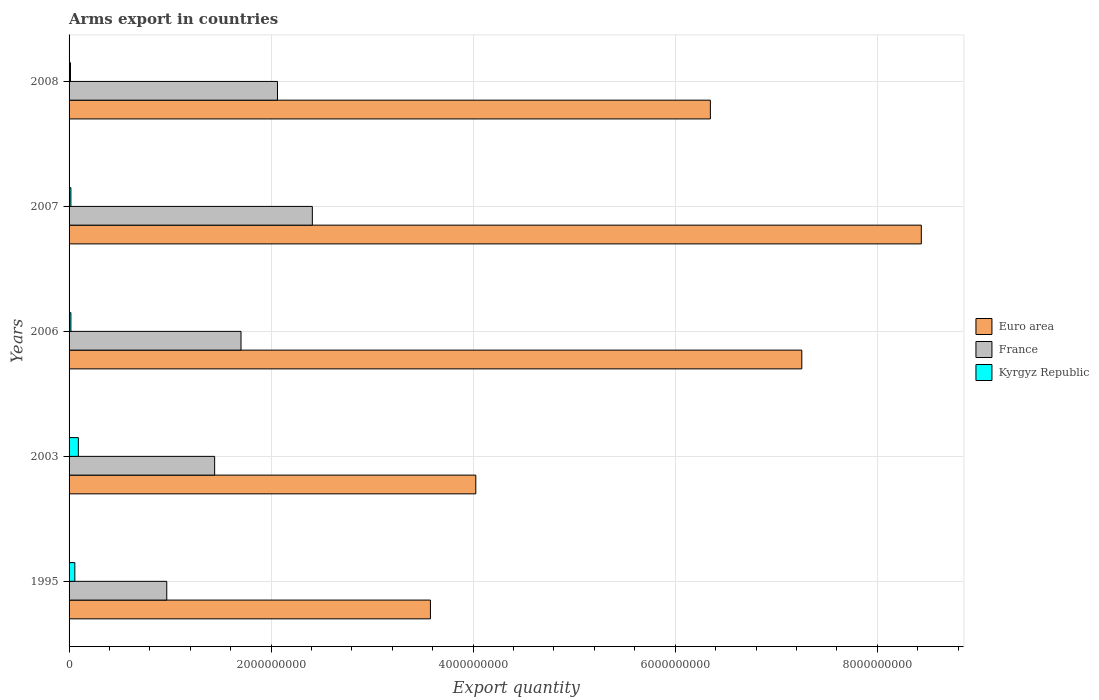Are the number of bars on each tick of the Y-axis equal?
Your answer should be compact. Yes. How many bars are there on the 3rd tick from the top?
Keep it short and to the point. 3. In how many cases, is the number of bars for a given year not equal to the number of legend labels?
Offer a terse response. 0. What is the total arms export in France in 2003?
Ensure brevity in your answer.  1.44e+09. Across all years, what is the maximum total arms export in Kyrgyz Republic?
Offer a very short reply. 9.20e+07. Across all years, what is the minimum total arms export in France?
Your answer should be very brief. 9.67e+08. What is the total total arms export in Euro area in the graph?
Make the answer very short. 2.96e+1. What is the difference between the total arms export in France in 2007 and that in 2008?
Keep it short and to the point. 3.45e+08. What is the difference between the total arms export in Euro area in 2006 and the total arms export in Kyrgyz Republic in 2003?
Your answer should be very brief. 7.16e+09. What is the average total arms export in France per year?
Your answer should be compact. 1.72e+09. In the year 2007, what is the difference between the total arms export in Euro area and total arms export in Kyrgyz Republic?
Make the answer very short. 8.42e+09. What is the ratio of the total arms export in Euro area in 2003 to that in 2006?
Offer a very short reply. 0.56. Is the total arms export in Euro area in 2003 less than that in 2006?
Make the answer very short. Yes. What is the difference between the highest and the second highest total arms export in Kyrgyz Republic?
Your answer should be compact. 3.50e+07. What is the difference between the highest and the lowest total arms export in France?
Your answer should be compact. 1.44e+09. Is the sum of the total arms export in Euro area in 1995 and 2008 greater than the maximum total arms export in Kyrgyz Republic across all years?
Make the answer very short. Yes. What does the 1st bar from the top in 1995 represents?
Keep it short and to the point. Kyrgyz Republic. What does the 3rd bar from the bottom in 2003 represents?
Your response must be concise. Kyrgyz Republic. How many bars are there?
Provide a succinct answer. 15. How many years are there in the graph?
Give a very brief answer. 5. What is the difference between two consecutive major ticks on the X-axis?
Provide a short and direct response. 2.00e+09. Does the graph contain grids?
Offer a very short reply. Yes. Where does the legend appear in the graph?
Your answer should be very brief. Center right. How are the legend labels stacked?
Keep it short and to the point. Vertical. What is the title of the graph?
Offer a very short reply. Arms export in countries. What is the label or title of the X-axis?
Your response must be concise. Export quantity. What is the Export quantity in Euro area in 1995?
Your answer should be very brief. 3.58e+09. What is the Export quantity of France in 1995?
Offer a terse response. 9.67e+08. What is the Export quantity in Kyrgyz Republic in 1995?
Give a very brief answer. 5.70e+07. What is the Export quantity in Euro area in 2003?
Make the answer very short. 4.03e+09. What is the Export quantity of France in 2003?
Your answer should be compact. 1.44e+09. What is the Export quantity of Kyrgyz Republic in 2003?
Provide a succinct answer. 9.20e+07. What is the Export quantity of Euro area in 2006?
Offer a terse response. 7.25e+09. What is the Export quantity of France in 2006?
Your response must be concise. 1.70e+09. What is the Export quantity of Kyrgyz Republic in 2006?
Keep it short and to the point. 1.80e+07. What is the Export quantity of Euro area in 2007?
Give a very brief answer. 8.44e+09. What is the Export quantity of France in 2007?
Offer a very short reply. 2.41e+09. What is the Export quantity in Kyrgyz Republic in 2007?
Offer a very short reply. 1.80e+07. What is the Export quantity of Euro area in 2008?
Provide a succinct answer. 6.35e+09. What is the Export quantity of France in 2008?
Provide a succinct answer. 2.06e+09. What is the Export quantity of Kyrgyz Republic in 2008?
Your answer should be compact. 1.40e+07. Across all years, what is the maximum Export quantity of Euro area?
Give a very brief answer. 8.44e+09. Across all years, what is the maximum Export quantity of France?
Your answer should be very brief. 2.41e+09. Across all years, what is the maximum Export quantity of Kyrgyz Republic?
Your answer should be very brief. 9.20e+07. Across all years, what is the minimum Export quantity of Euro area?
Make the answer very short. 3.58e+09. Across all years, what is the minimum Export quantity of France?
Your answer should be compact. 9.67e+08. Across all years, what is the minimum Export quantity of Kyrgyz Republic?
Your answer should be compact. 1.40e+07. What is the total Export quantity in Euro area in the graph?
Your answer should be compact. 2.96e+1. What is the total Export quantity of France in the graph?
Provide a short and direct response. 8.58e+09. What is the total Export quantity of Kyrgyz Republic in the graph?
Your answer should be very brief. 1.99e+08. What is the difference between the Export quantity of Euro area in 1995 and that in 2003?
Your response must be concise. -4.49e+08. What is the difference between the Export quantity in France in 1995 and that in 2003?
Your answer should be very brief. -4.74e+08. What is the difference between the Export quantity of Kyrgyz Republic in 1995 and that in 2003?
Your response must be concise. -3.50e+07. What is the difference between the Export quantity of Euro area in 1995 and that in 2006?
Your answer should be compact. -3.68e+09. What is the difference between the Export quantity of France in 1995 and that in 2006?
Your answer should be compact. -7.35e+08. What is the difference between the Export quantity of Kyrgyz Republic in 1995 and that in 2006?
Your answer should be very brief. 3.90e+07. What is the difference between the Export quantity of Euro area in 1995 and that in 2007?
Provide a short and direct response. -4.86e+09. What is the difference between the Export quantity in France in 1995 and that in 2007?
Keep it short and to the point. -1.44e+09. What is the difference between the Export quantity of Kyrgyz Republic in 1995 and that in 2007?
Your response must be concise. 3.90e+07. What is the difference between the Export quantity in Euro area in 1995 and that in 2008?
Offer a terse response. -2.77e+09. What is the difference between the Export quantity of France in 1995 and that in 2008?
Give a very brief answer. -1.10e+09. What is the difference between the Export quantity in Kyrgyz Republic in 1995 and that in 2008?
Give a very brief answer. 4.30e+07. What is the difference between the Export quantity in Euro area in 2003 and that in 2006?
Offer a very short reply. -3.23e+09. What is the difference between the Export quantity in France in 2003 and that in 2006?
Offer a terse response. -2.61e+08. What is the difference between the Export quantity in Kyrgyz Republic in 2003 and that in 2006?
Offer a very short reply. 7.40e+07. What is the difference between the Export quantity of Euro area in 2003 and that in 2007?
Offer a very short reply. -4.41e+09. What is the difference between the Export quantity in France in 2003 and that in 2007?
Provide a succinct answer. -9.67e+08. What is the difference between the Export quantity of Kyrgyz Republic in 2003 and that in 2007?
Provide a short and direct response. 7.40e+07. What is the difference between the Export quantity of Euro area in 2003 and that in 2008?
Provide a succinct answer. -2.32e+09. What is the difference between the Export quantity in France in 2003 and that in 2008?
Your answer should be compact. -6.22e+08. What is the difference between the Export quantity in Kyrgyz Republic in 2003 and that in 2008?
Give a very brief answer. 7.80e+07. What is the difference between the Export quantity of Euro area in 2006 and that in 2007?
Your answer should be very brief. -1.18e+09. What is the difference between the Export quantity in France in 2006 and that in 2007?
Offer a terse response. -7.06e+08. What is the difference between the Export quantity of Euro area in 2006 and that in 2008?
Keep it short and to the point. 9.05e+08. What is the difference between the Export quantity in France in 2006 and that in 2008?
Keep it short and to the point. -3.61e+08. What is the difference between the Export quantity in Euro area in 2007 and that in 2008?
Your answer should be compact. 2.09e+09. What is the difference between the Export quantity of France in 2007 and that in 2008?
Give a very brief answer. 3.45e+08. What is the difference between the Export quantity of Euro area in 1995 and the Export quantity of France in 2003?
Offer a terse response. 2.14e+09. What is the difference between the Export quantity in Euro area in 1995 and the Export quantity in Kyrgyz Republic in 2003?
Offer a very short reply. 3.48e+09. What is the difference between the Export quantity of France in 1995 and the Export quantity of Kyrgyz Republic in 2003?
Offer a terse response. 8.75e+08. What is the difference between the Export quantity in Euro area in 1995 and the Export quantity in France in 2006?
Provide a succinct answer. 1.88e+09. What is the difference between the Export quantity of Euro area in 1995 and the Export quantity of Kyrgyz Republic in 2006?
Your response must be concise. 3.56e+09. What is the difference between the Export quantity of France in 1995 and the Export quantity of Kyrgyz Republic in 2006?
Offer a terse response. 9.49e+08. What is the difference between the Export quantity of Euro area in 1995 and the Export quantity of France in 2007?
Offer a very short reply. 1.17e+09. What is the difference between the Export quantity in Euro area in 1995 and the Export quantity in Kyrgyz Republic in 2007?
Ensure brevity in your answer.  3.56e+09. What is the difference between the Export quantity of France in 1995 and the Export quantity of Kyrgyz Republic in 2007?
Provide a short and direct response. 9.49e+08. What is the difference between the Export quantity of Euro area in 1995 and the Export quantity of France in 2008?
Keep it short and to the point. 1.51e+09. What is the difference between the Export quantity in Euro area in 1995 and the Export quantity in Kyrgyz Republic in 2008?
Keep it short and to the point. 3.56e+09. What is the difference between the Export quantity in France in 1995 and the Export quantity in Kyrgyz Republic in 2008?
Provide a short and direct response. 9.53e+08. What is the difference between the Export quantity in Euro area in 2003 and the Export quantity in France in 2006?
Provide a succinct answer. 2.32e+09. What is the difference between the Export quantity of Euro area in 2003 and the Export quantity of Kyrgyz Republic in 2006?
Make the answer very short. 4.01e+09. What is the difference between the Export quantity of France in 2003 and the Export quantity of Kyrgyz Republic in 2006?
Keep it short and to the point. 1.42e+09. What is the difference between the Export quantity in Euro area in 2003 and the Export quantity in France in 2007?
Keep it short and to the point. 1.62e+09. What is the difference between the Export quantity in Euro area in 2003 and the Export quantity in Kyrgyz Republic in 2007?
Make the answer very short. 4.01e+09. What is the difference between the Export quantity of France in 2003 and the Export quantity of Kyrgyz Republic in 2007?
Provide a succinct answer. 1.42e+09. What is the difference between the Export quantity in Euro area in 2003 and the Export quantity in France in 2008?
Your response must be concise. 1.96e+09. What is the difference between the Export quantity of Euro area in 2003 and the Export quantity of Kyrgyz Republic in 2008?
Your response must be concise. 4.01e+09. What is the difference between the Export quantity of France in 2003 and the Export quantity of Kyrgyz Republic in 2008?
Offer a terse response. 1.43e+09. What is the difference between the Export quantity of Euro area in 2006 and the Export quantity of France in 2007?
Provide a succinct answer. 4.84e+09. What is the difference between the Export quantity of Euro area in 2006 and the Export quantity of Kyrgyz Republic in 2007?
Your response must be concise. 7.24e+09. What is the difference between the Export quantity in France in 2006 and the Export quantity in Kyrgyz Republic in 2007?
Your answer should be compact. 1.68e+09. What is the difference between the Export quantity in Euro area in 2006 and the Export quantity in France in 2008?
Provide a succinct answer. 5.19e+09. What is the difference between the Export quantity in Euro area in 2006 and the Export quantity in Kyrgyz Republic in 2008?
Provide a succinct answer. 7.24e+09. What is the difference between the Export quantity in France in 2006 and the Export quantity in Kyrgyz Republic in 2008?
Keep it short and to the point. 1.69e+09. What is the difference between the Export quantity of Euro area in 2007 and the Export quantity of France in 2008?
Ensure brevity in your answer.  6.37e+09. What is the difference between the Export quantity of Euro area in 2007 and the Export quantity of Kyrgyz Republic in 2008?
Make the answer very short. 8.42e+09. What is the difference between the Export quantity of France in 2007 and the Export quantity of Kyrgyz Republic in 2008?
Your answer should be very brief. 2.39e+09. What is the average Export quantity of Euro area per year?
Provide a short and direct response. 5.93e+09. What is the average Export quantity of France per year?
Your response must be concise. 1.72e+09. What is the average Export quantity in Kyrgyz Republic per year?
Make the answer very short. 3.98e+07. In the year 1995, what is the difference between the Export quantity of Euro area and Export quantity of France?
Your response must be concise. 2.61e+09. In the year 1995, what is the difference between the Export quantity in Euro area and Export quantity in Kyrgyz Republic?
Your response must be concise. 3.52e+09. In the year 1995, what is the difference between the Export quantity of France and Export quantity of Kyrgyz Republic?
Keep it short and to the point. 9.10e+08. In the year 2003, what is the difference between the Export quantity in Euro area and Export quantity in France?
Make the answer very short. 2.58e+09. In the year 2003, what is the difference between the Export quantity of Euro area and Export quantity of Kyrgyz Republic?
Your response must be concise. 3.93e+09. In the year 2003, what is the difference between the Export quantity in France and Export quantity in Kyrgyz Republic?
Make the answer very short. 1.35e+09. In the year 2006, what is the difference between the Export quantity of Euro area and Export quantity of France?
Provide a succinct answer. 5.55e+09. In the year 2006, what is the difference between the Export quantity of Euro area and Export quantity of Kyrgyz Republic?
Offer a terse response. 7.24e+09. In the year 2006, what is the difference between the Export quantity in France and Export quantity in Kyrgyz Republic?
Ensure brevity in your answer.  1.68e+09. In the year 2007, what is the difference between the Export quantity of Euro area and Export quantity of France?
Your answer should be very brief. 6.03e+09. In the year 2007, what is the difference between the Export quantity of Euro area and Export quantity of Kyrgyz Republic?
Make the answer very short. 8.42e+09. In the year 2007, what is the difference between the Export quantity in France and Export quantity in Kyrgyz Republic?
Offer a terse response. 2.39e+09. In the year 2008, what is the difference between the Export quantity of Euro area and Export quantity of France?
Provide a short and direct response. 4.28e+09. In the year 2008, what is the difference between the Export quantity of Euro area and Export quantity of Kyrgyz Republic?
Your response must be concise. 6.33e+09. In the year 2008, what is the difference between the Export quantity of France and Export quantity of Kyrgyz Republic?
Offer a terse response. 2.05e+09. What is the ratio of the Export quantity of Euro area in 1995 to that in 2003?
Your response must be concise. 0.89. What is the ratio of the Export quantity of France in 1995 to that in 2003?
Your response must be concise. 0.67. What is the ratio of the Export quantity of Kyrgyz Republic in 1995 to that in 2003?
Provide a succinct answer. 0.62. What is the ratio of the Export quantity of Euro area in 1995 to that in 2006?
Make the answer very short. 0.49. What is the ratio of the Export quantity in France in 1995 to that in 2006?
Provide a succinct answer. 0.57. What is the ratio of the Export quantity of Kyrgyz Republic in 1995 to that in 2006?
Make the answer very short. 3.17. What is the ratio of the Export quantity in Euro area in 1995 to that in 2007?
Provide a short and direct response. 0.42. What is the ratio of the Export quantity of France in 1995 to that in 2007?
Ensure brevity in your answer.  0.4. What is the ratio of the Export quantity of Kyrgyz Republic in 1995 to that in 2007?
Ensure brevity in your answer.  3.17. What is the ratio of the Export quantity of Euro area in 1995 to that in 2008?
Offer a terse response. 0.56. What is the ratio of the Export quantity in France in 1995 to that in 2008?
Give a very brief answer. 0.47. What is the ratio of the Export quantity of Kyrgyz Republic in 1995 to that in 2008?
Your answer should be very brief. 4.07. What is the ratio of the Export quantity of Euro area in 2003 to that in 2006?
Provide a succinct answer. 0.56. What is the ratio of the Export quantity in France in 2003 to that in 2006?
Keep it short and to the point. 0.85. What is the ratio of the Export quantity in Kyrgyz Republic in 2003 to that in 2006?
Ensure brevity in your answer.  5.11. What is the ratio of the Export quantity of Euro area in 2003 to that in 2007?
Make the answer very short. 0.48. What is the ratio of the Export quantity in France in 2003 to that in 2007?
Ensure brevity in your answer.  0.6. What is the ratio of the Export quantity of Kyrgyz Republic in 2003 to that in 2007?
Provide a short and direct response. 5.11. What is the ratio of the Export quantity of Euro area in 2003 to that in 2008?
Your answer should be very brief. 0.63. What is the ratio of the Export quantity in France in 2003 to that in 2008?
Provide a succinct answer. 0.7. What is the ratio of the Export quantity in Kyrgyz Republic in 2003 to that in 2008?
Ensure brevity in your answer.  6.57. What is the ratio of the Export quantity in Euro area in 2006 to that in 2007?
Your answer should be very brief. 0.86. What is the ratio of the Export quantity of France in 2006 to that in 2007?
Your answer should be very brief. 0.71. What is the ratio of the Export quantity of Kyrgyz Republic in 2006 to that in 2007?
Offer a terse response. 1. What is the ratio of the Export quantity of Euro area in 2006 to that in 2008?
Make the answer very short. 1.14. What is the ratio of the Export quantity in France in 2006 to that in 2008?
Make the answer very short. 0.82. What is the ratio of the Export quantity in Euro area in 2007 to that in 2008?
Your response must be concise. 1.33. What is the ratio of the Export quantity in France in 2007 to that in 2008?
Your response must be concise. 1.17. What is the ratio of the Export quantity in Kyrgyz Republic in 2007 to that in 2008?
Provide a short and direct response. 1.29. What is the difference between the highest and the second highest Export quantity of Euro area?
Your answer should be compact. 1.18e+09. What is the difference between the highest and the second highest Export quantity in France?
Provide a short and direct response. 3.45e+08. What is the difference between the highest and the second highest Export quantity in Kyrgyz Republic?
Make the answer very short. 3.50e+07. What is the difference between the highest and the lowest Export quantity in Euro area?
Your response must be concise. 4.86e+09. What is the difference between the highest and the lowest Export quantity in France?
Ensure brevity in your answer.  1.44e+09. What is the difference between the highest and the lowest Export quantity of Kyrgyz Republic?
Make the answer very short. 7.80e+07. 